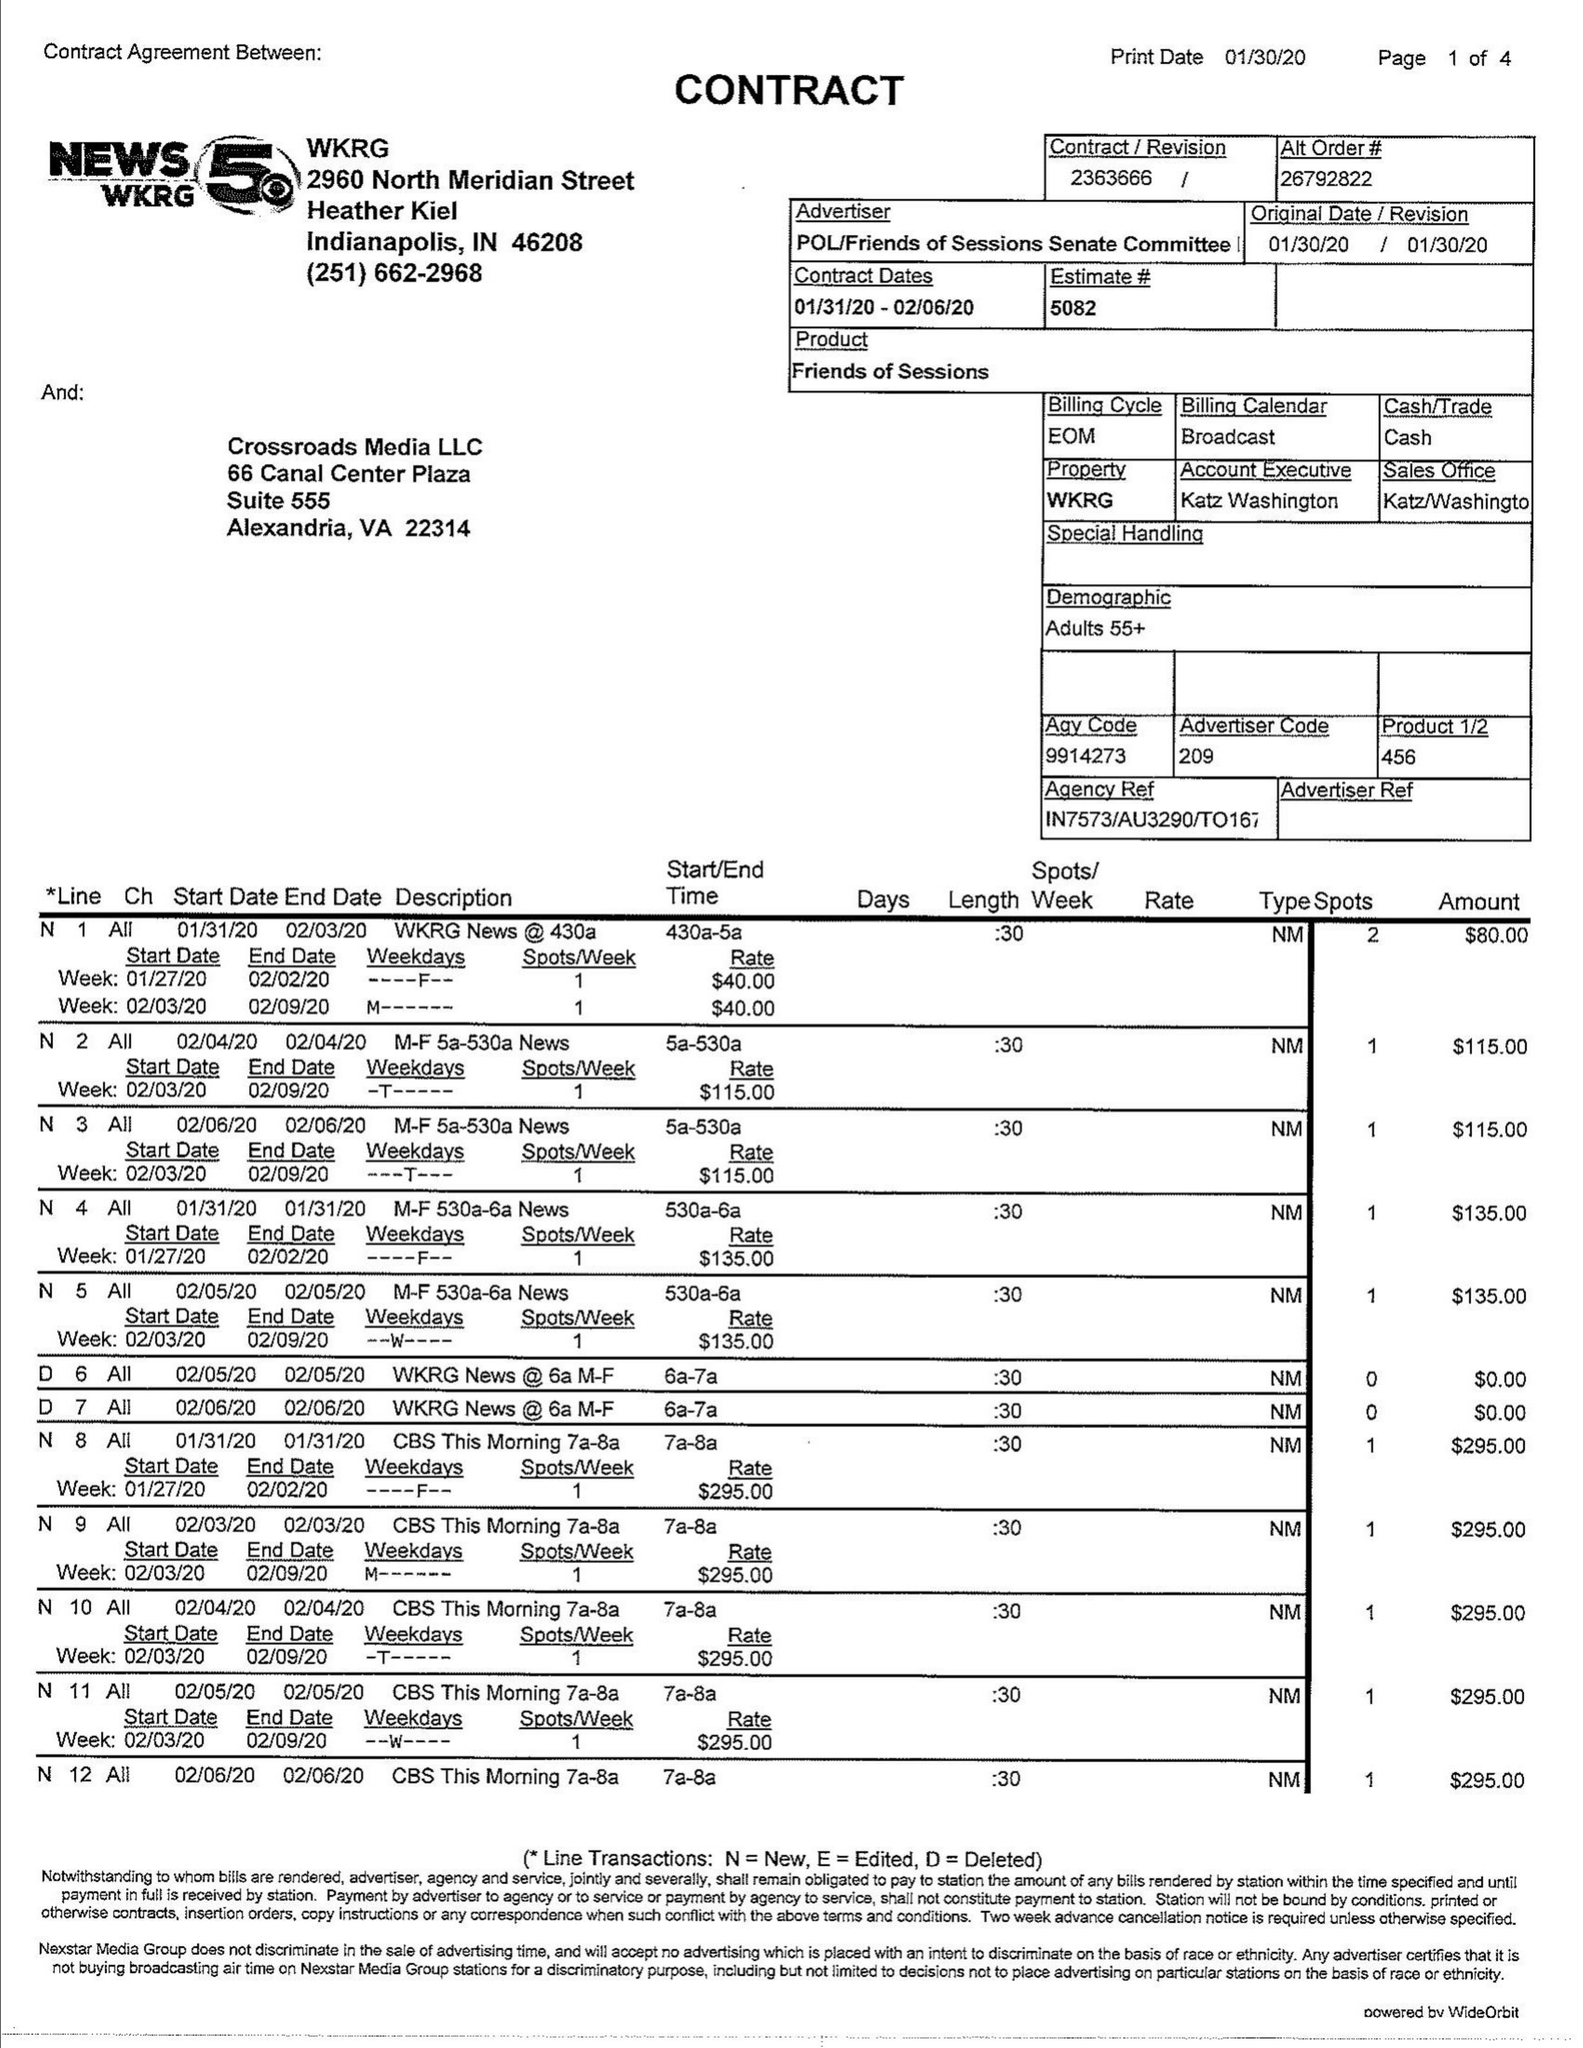What is the value for the flight_from?
Answer the question using a single word or phrase. 01/31/20 